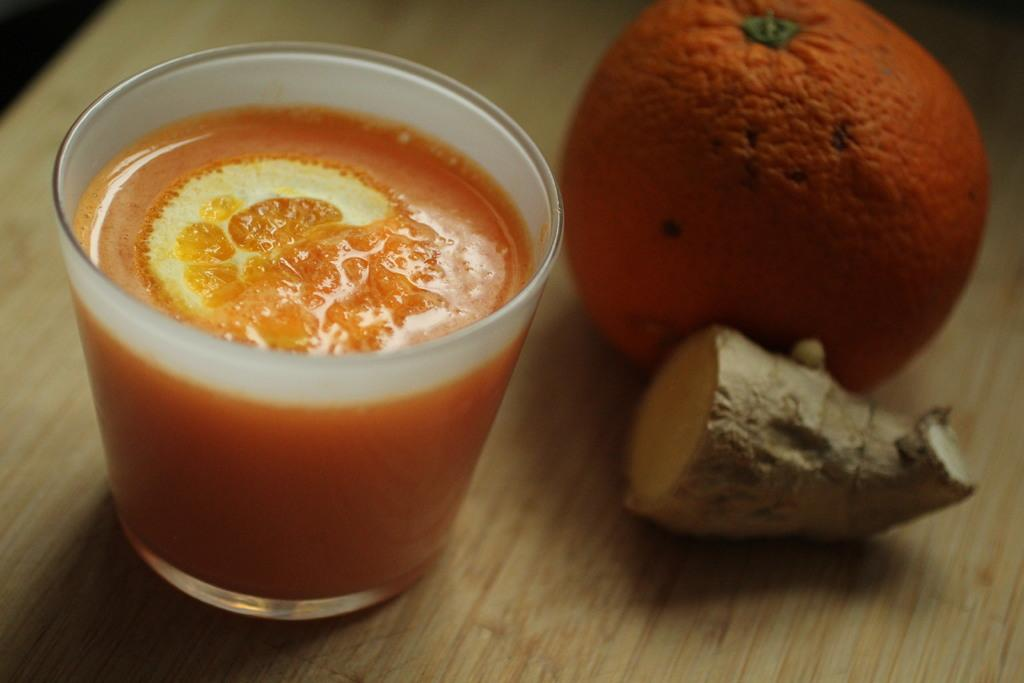What is in the glass that is visible in the image? There is a glass with juice in the image. What fruit is present in the image? There is an orange in the image. What spice is present on the table in the image? Ginger is present on the table in the image. How many stamps are on the orange in the image? There are no stamps on the orange in the image; it is a fruit. 